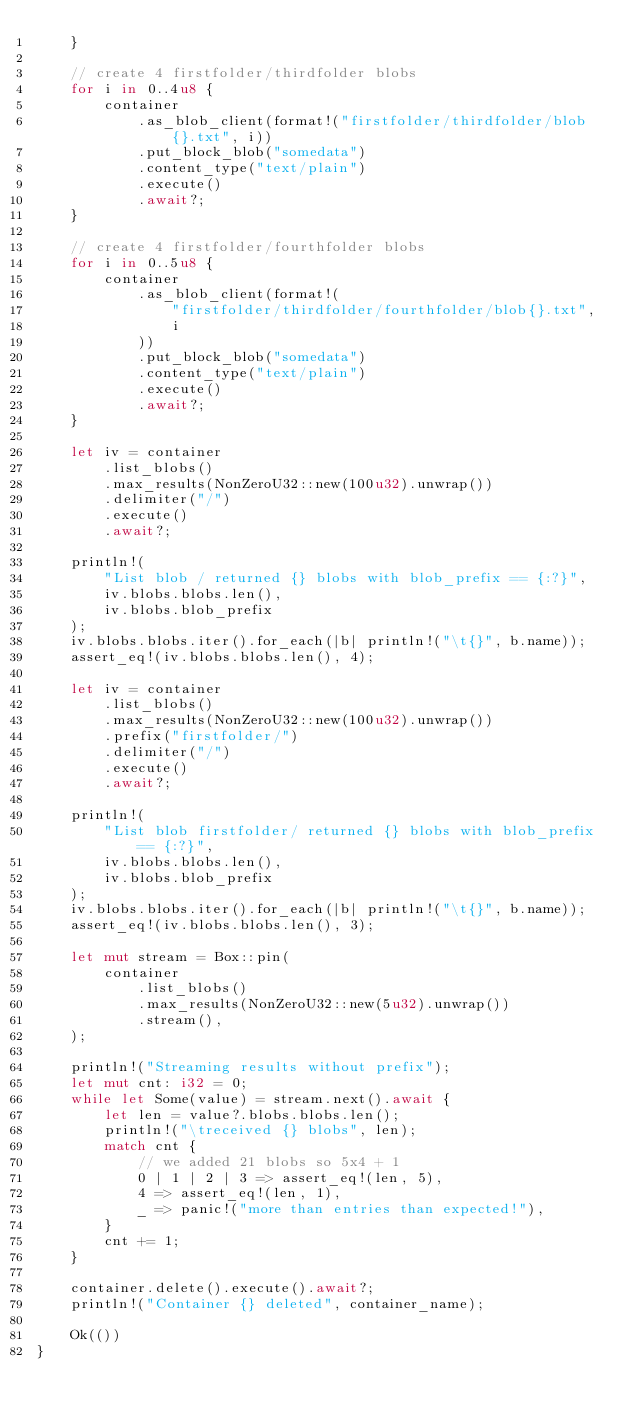<code> <loc_0><loc_0><loc_500><loc_500><_Rust_>    }

    // create 4 firstfolder/thirdfolder blobs
    for i in 0..4u8 {
        container
            .as_blob_client(format!("firstfolder/thirdfolder/blob{}.txt", i))
            .put_block_blob("somedata")
            .content_type("text/plain")
            .execute()
            .await?;
    }

    // create 4 firstfolder/fourthfolder blobs
    for i in 0..5u8 {
        container
            .as_blob_client(format!(
                "firstfolder/thirdfolder/fourthfolder/blob{}.txt",
                i
            ))
            .put_block_blob("somedata")
            .content_type("text/plain")
            .execute()
            .await?;
    }

    let iv = container
        .list_blobs()
        .max_results(NonZeroU32::new(100u32).unwrap())
        .delimiter("/")
        .execute()
        .await?;

    println!(
        "List blob / returned {} blobs with blob_prefix == {:?}",
        iv.blobs.blobs.len(),
        iv.blobs.blob_prefix
    );
    iv.blobs.blobs.iter().for_each(|b| println!("\t{}", b.name));
    assert_eq!(iv.blobs.blobs.len(), 4);

    let iv = container
        .list_blobs()
        .max_results(NonZeroU32::new(100u32).unwrap())
        .prefix("firstfolder/")
        .delimiter("/")
        .execute()
        .await?;

    println!(
        "List blob firstfolder/ returned {} blobs with blob_prefix == {:?}",
        iv.blobs.blobs.len(),
        iv.blobs.blob_prefix
    );
    iv.blobs.blobs.iter().for_each(|b| println!("\t{}", b.name));
    assert_eq!(iv.blobs.blobs.len(), 3);

    let mut stream = Box::pin(
        container
            .list_blobs()
            .max_results(NonZeroU32::new(5u32).unwrap())
            .stream(),
    );

    println!("Streaming results without prefix");
    let mut cnt: i32 = 0;
    while let Some(value) = stream.next().await {
        let len = value?.blobs.blobs.len();
        println!("\treceived {} blobs", len);
        match cnt {
            // we added 21 blobs so 5x4 + 1
            0 | 1 | 2 | 3 => assert_eq!(len, 5),
            4 => assert_eq!(len, 1),
            _ => panic!("more than entries than expected!"),
        }
        cnt += 1;
    }

    container.delete().execute().await?;
    println!("Container {} deleted", container_name);

    Ok(())
}
</code> 